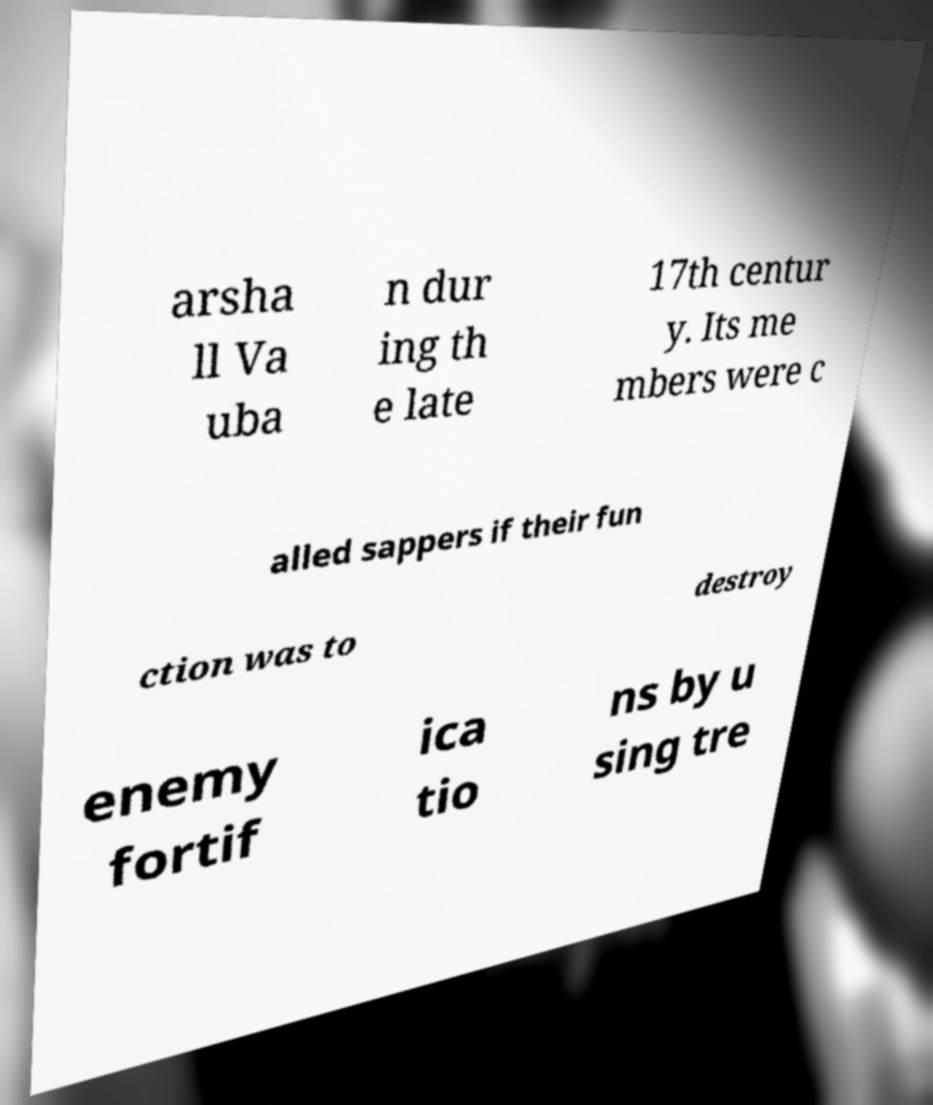Could you extract and type out the text from this image? arsha ll Va uba n dur ing th e late 17th centur y. Its me mbers were c alled sappers if their fun ction was to destroy enemy fortif ica tio ns by u sing tre 